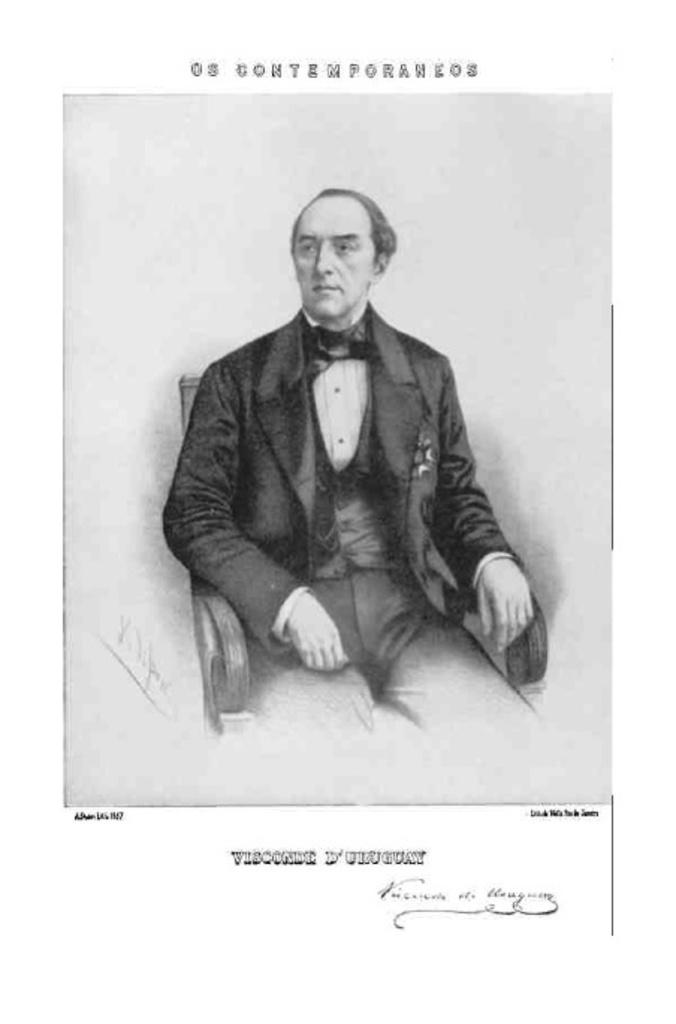What is the main subject of the image? The main subject of the image is a sketch of a person. Where is the text located in the image? There is text in the top and bottom of the image. What type of polish is being applied to the person's teeth in the image? There is no polish or teeth present in the image; it features a sketch of a person and text. What time of day is depicted in the image? The image does not depict a specific time of day, as it is a sketch of a person with text. 